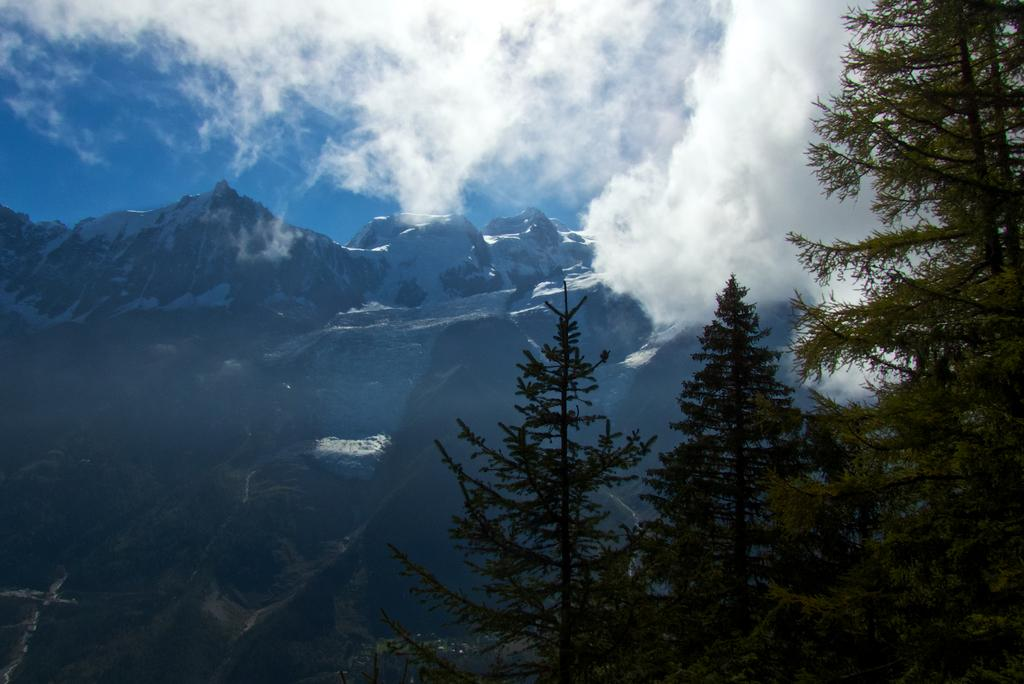What type of natural environment is depicted in the image? The image features many trees, indicating a forest or wooded area. What can be seen in the background of the image? There are tall mountains behind the trees in the image. What type of cheese is being served on the furniture in the image? There is no cheese or furniture present in the image; it only features trees and mountains. 